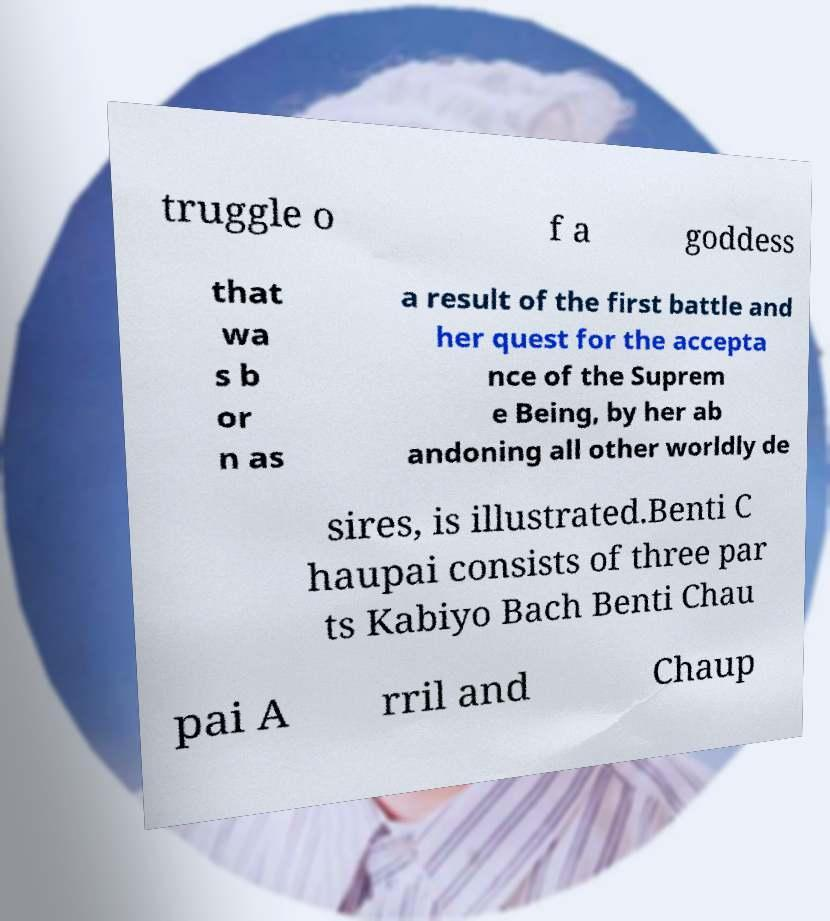Can you read and provide the text displayed in the image?This photo seems to have some interesting text. Can you extract and type it out for me? truggle o f a goddess that wa s b or n as a result of the first battle and her quest for the accepta nce of the Suprem e Being, by her ab andoning all other worldly de sires, is illustrated.Benti C haupai consists of three par ts Kabiyo Bach Benti Chau pai A rril and Chaup 